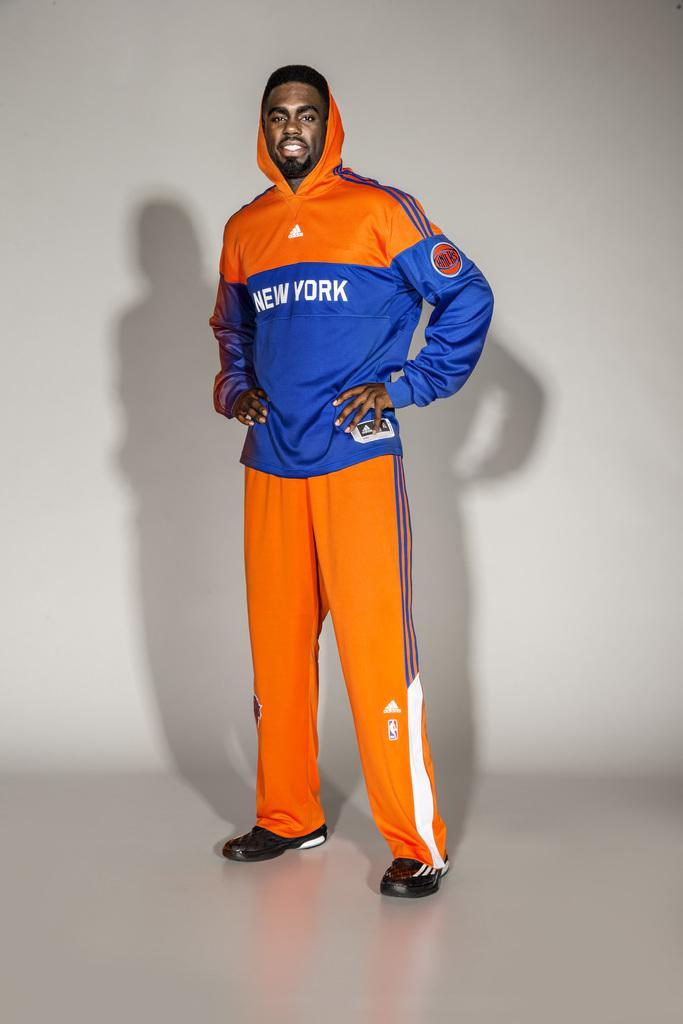<image>
Write a terse but informative summary of the picture. New York outfit with a knicks logo and adidas logo. 